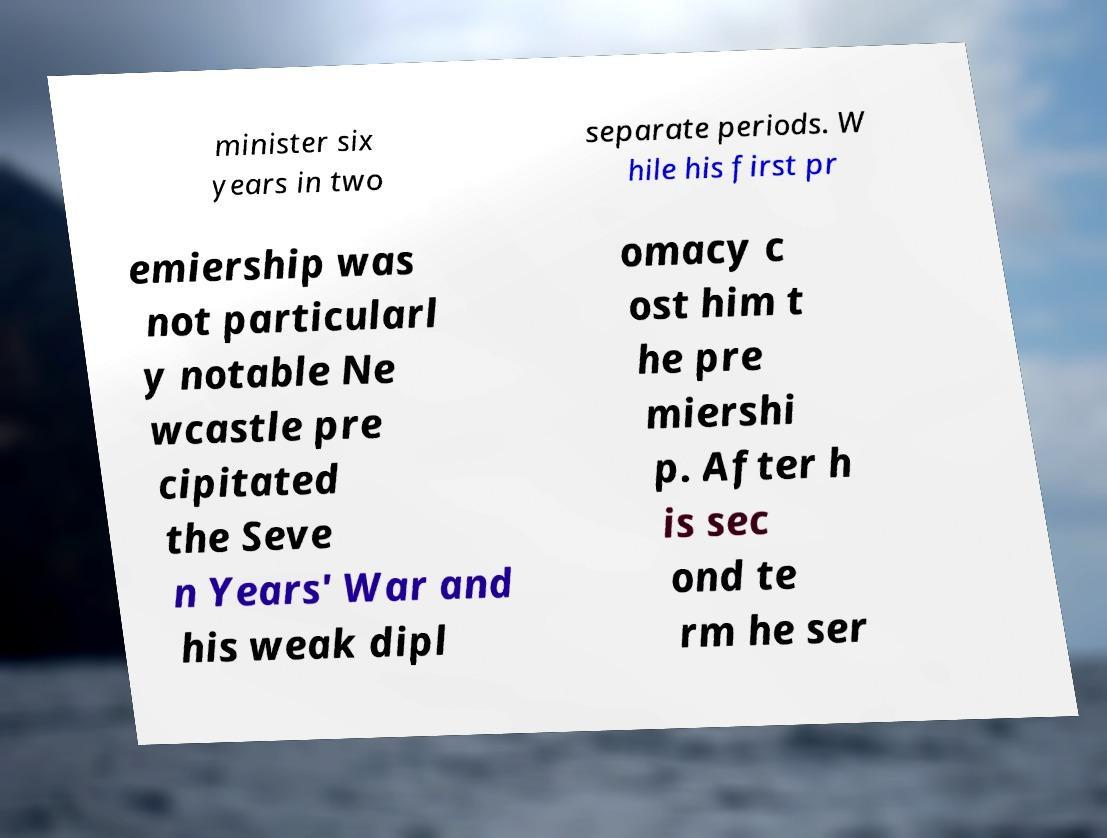Could you assist in decoding the text presented in this image and type it out clearly? minister six years in two separate periods. W hile his first pr emiership was not particularl y notable Ne wcastle pre cipitated the Seve n Years' War and his weak dipl omacy c ost him t he pre miershi p. After h is sec ond te rm he ser 